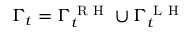<formula> <loc_0><loc_0><loc_500><loc_500>\Gamma _ { t } = \Gamma _ { t } ^ { R H } \cup \Gamma _ { t } ^ { L H }</formula> 